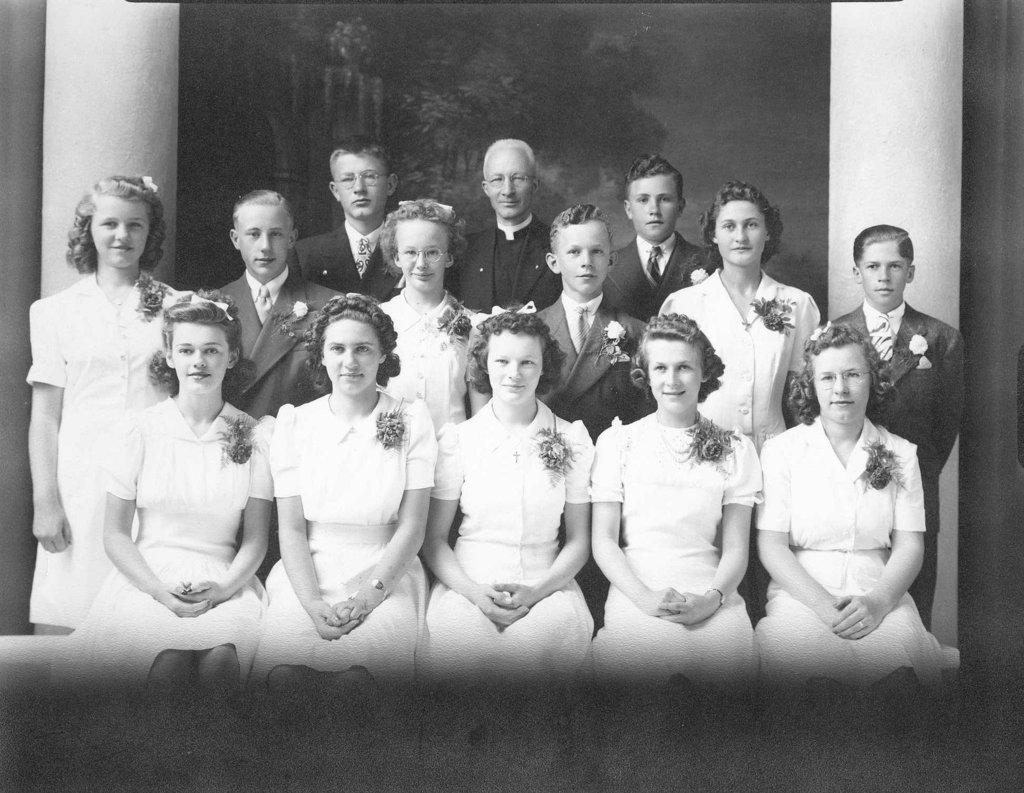What are the people in the foreground of the image doing? Some of the persons are sitting, while others are standing, and they are posing for the camera. Can you describe the positions of the people in the image? Some are sitting, and others are standing. What can be seen in the background of the image? There is a scenery wall and two pillars in the background of the image. What type of nut is being served on the tray in the image? There is no tray or nut present in the image. How many times did the person in the image cough during the photo session? There is no indication of anyone coughing in the image. 